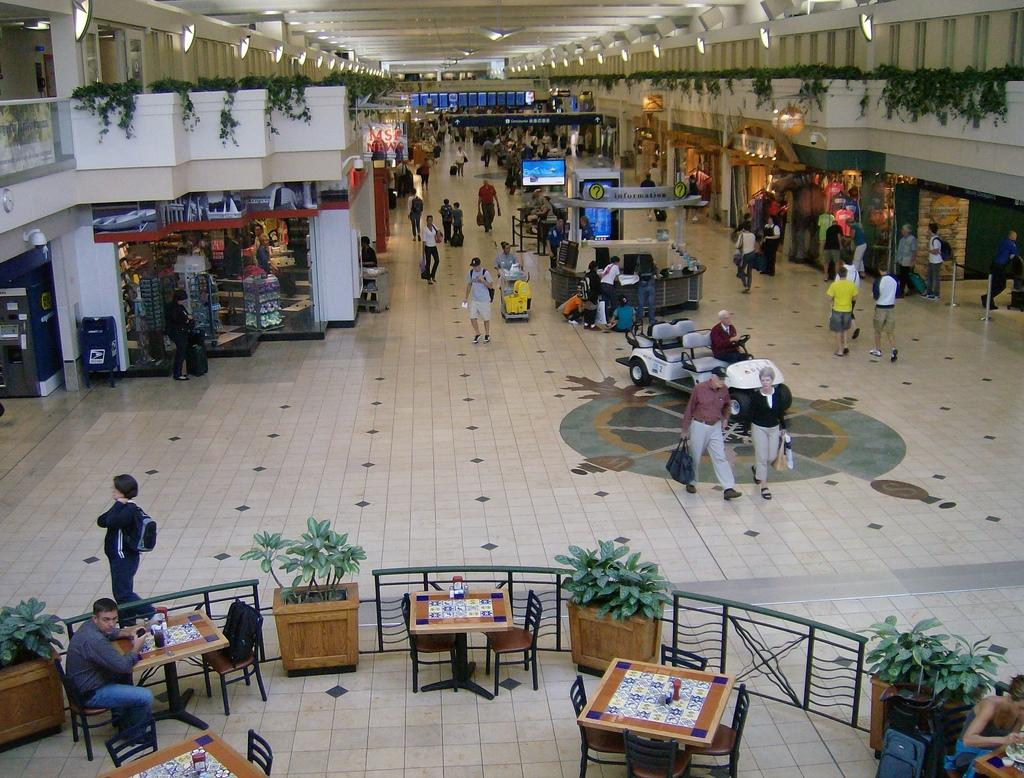How many people are in the image? There is a group of people in the image, but the exact number cannot be determined from the provided facts. What type of structures are present in the image? There are stalls in the image. What can be seen illuminating the scene in the image? There are lights in the image. What type of vegetation is present in the image? There are plants in the image. What type of furniture is present in the image? Chairs and tables are present in the image. What is located at the bottom of the image? There are items placed on the bottom of the image, but their specific nature cannot be determined from the provided facts. How many elbows can be seen in the image? There is no information about elbows in the provided facts, so it cannot be determined from the image. 